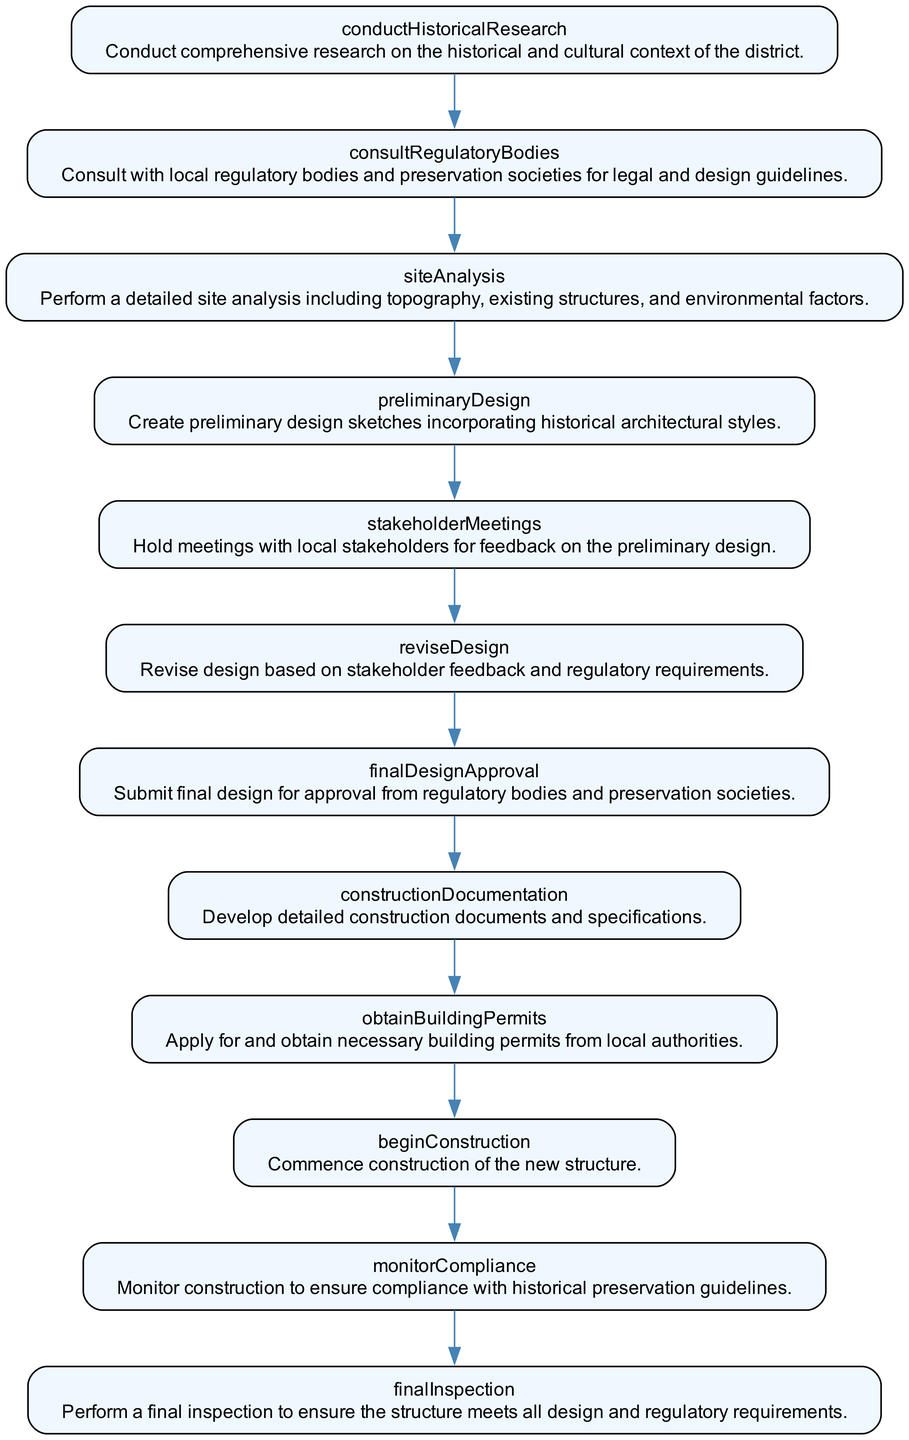What is the first step in the process? The first step in the flowchart is "conductHistoricalResearch." This is identified as the initial node before any other processes unfold.
Answer: conductHistoricalResearch How many nodes are in the diagram? The diagram includes twelve nodes, each representing a step in the design process. By counting all the distinct steps listed, we find there are twelve.
Answer: twelve What comes after "siteAnalysis"? The step that follows "siteAnalysis" in the flowchart is "preliminaryDesign." It shows a progression from analyzing the site to creating the design.
Answer: preliminaryDesign Which step involves feedback from stakeholders? The step that involves feedback from stakeholders is "stakeholderMeetings." This step specifically indicates engagement with stakeholders to gather their input on the design.
Answer: stakeholderMeetings Which action must be taken before construction begins? Before construction can commence, one must "obtainBuildingPermits." This is a requisite action that ensures legal authorization before starting the physical work.
Answer: obtainBuildingPermits What steps are required before submitting the final design for approval? The steps required before submission are "reviseDesign" and "finalDesignApproval." After revising based on feedback, one prepares the final design for approval from regulatory bodies.
Answer: reviseDesign, finalDesignApproval What is the last step in the design process according to the flowchart? The last step in the flowchart is "finalInspection." This indicates the conclusion of the process where the structure is evaluated for compliance with requirements.
Answer: finalInspection How many edges are in the flowchart? There are eleven edges in the flowchart, which connect the twelve nodes. Each edge represents the flow from one step to the next, totaling to eleven transitions.
Answer: eleven What type of reports should be created as part of the construction documentation? The type of reports that should be included in "constructionDocumentation" encompasses detailed construction documents and specifications. This step specifically indicates the necessity of formal documentation.
Answer: detailed construction documents and specifications 